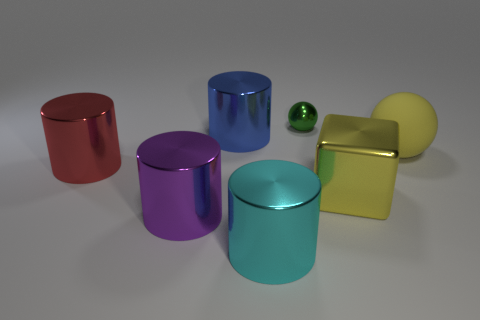There is a thing behind the large metal thing that is behind the big yellow matte sphere; what is its shape?
Offer a terse response. Sphere. Are there fewer big red shiny cylinders on the right side of the big cyan cylinder than yellow blocks?
Offer a terse response. Yes. What is the shape of the tiny green object?
Offer a very short reply. Sphere. There is a metal cylinder that is behind the large red cylinder; what is its size?
Your answer should be very brief. Large. There is a cube that is the same size as the cyan metallic object; what color is it?
Give a very brief answer. Yellow. Is there a ball that has the same color as the big cube?
Provide a short and direct response. Yes. Is the number of big yellow shiny objects that are on the right side of the yellow shiny cube less than the number of large cylinders in front of the red metal cylinder?
Your answer should be compact. Yes. The object that is behind the matte sphere and left of the large cyan cylinder is made of what material?
Your answer should be very brief. Metal. There is a green shiny thing; is it the same shape as the big blue shiny thing behind the block?
Your answer should be compact. No. How many other things are the same size as the red metallic object?
Keep it short and to the point. 5. 